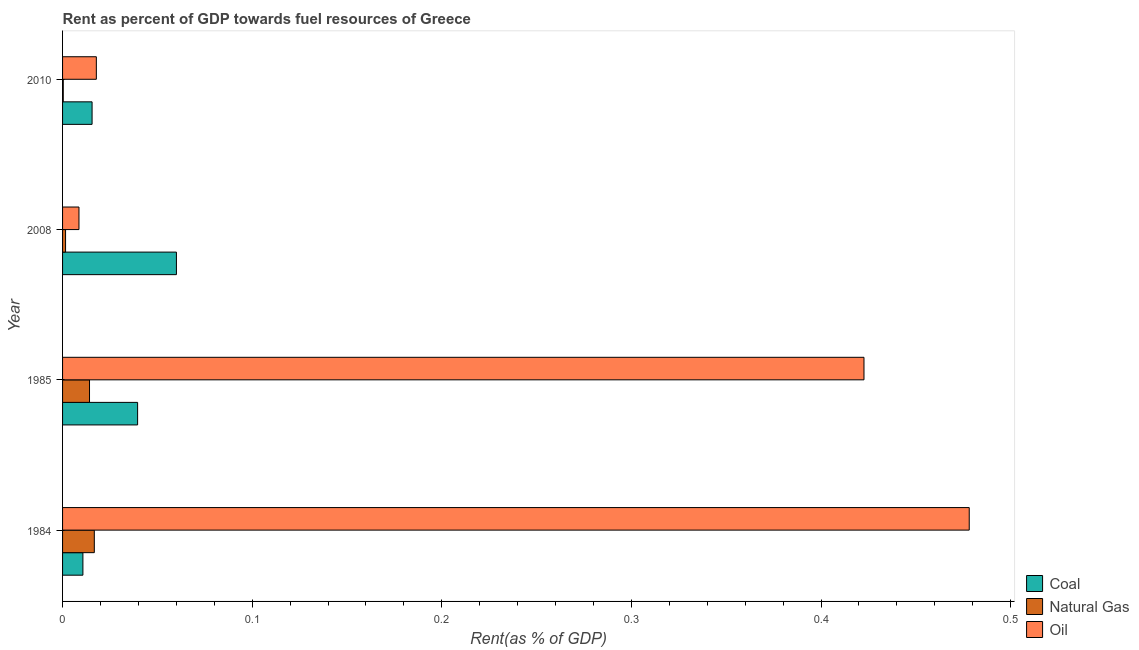What is the label of the 4th group of bars from the top?
Keep it short and to the point. 1984. What is the rent towards natural gas in 2010?
Your answer should be very brief. 0. Across all years, what is the maximum rent towards coal?
Keep it short and to the point. 0.06. Across all years, what is the minimum rent towards natural gas?
Your response must be concise. 0. In which year was the rent towards oil minimum?
Provide a succinct answer. 2008. What is the total rent towards coal in the graph?
Offer a terse response. 0.13. What is the difference between the rent towards coal in 2008 and that in 2010?
Offer a very short reply. 0.04. What is the difference between the rent towards coal in 1985 and the rent towards oil in 2010?
Offer a terse response. 0.02. What is the average rent towards natural gas per year?
Your answer should be very brief. 0.01. In the year 2010, what is the difference between the rent towards coal and rent towards oil?
Provide a succinct answer. -0. What is the ratio of the rent towards natural gas in 2008 to that in 2010?
Give a very brief answer. 4.28. Is the difference between the rent towards oil in 1984 and 2010 greater than the difference between the rent towards coal in 1984 and 2010?
Give a very brief answer. Yes. What is the difference between the highest and the lowest rent towards coal?
Provide a short and direct response. 0.05. In how many years, is the rent towards oil greater than the average rent towards oil taken over all years?
Provide a succinct answer. 2. What does the 3rd bar from the top in 2010 represents?
Provide a short and direct response. Coal. What does the 1st bar from the bottom in 2010 represents?
Your response must be concise. Coal. How many bars are there?
Keep it short and to the point. 12. How many years are there in the graph?
Your answer should be very brief. 4. Where does the legend appear in the graph?
Give a very brief answer. Bottom right. What is the title of the graph?
Ensure brevity in your answer.  Rent as percent of GDP towards fuel resources of Greece. What is the label or title of the X-axis?
Your response must be concise. Rent(as % of GDP). What is the Rent(as % of GDP) in Coal in 1984?
Offer a very short reply. 0.01. What is the Rent(as % of GDP) in Natural Gas in 1984?
Offer a terse response. 0.02. What is the Rent(as % of GDP) in Oil in 1984?
Offer a very short reply. 0.48. What is the Rent(as % of GDP) in Coal in 1985?
Offer a very short reply. 0.04. What is the Rent(as % of GDP) in Natural Gas in 1985?
Your answer should be compact. 0.01. What is the Rent(as % of GDP) in Oil in 1985?
Your answer should be compact. 0.42. What is the Rent(as % of GDP) of Coal in 2008?
Keep it short and to the point. 0.06. What is the Rent(as % of GDP) of Natural Gas in 2008?
Offer a very short reply. 0. What is the Rent(as % of GDP) in Oil in 2008?
Your answer should be very brief. 0.01. What is the Rent(as % of GDP) of Coal in 2010?
Your answer should be compact. 0.02. What is the Rent(as % of GDP) in Natural Gas in 2010?
Make the answer very short. 0. What is the Rent(as % of GDP) of Oil in 2010?
Your answer should be very brief. 0.02. Across all years, what is the maximum Rent(as % of GDP) of Coal?
Your answer should be very brief. 0.06. Across all years, what is the maximum Rent(as % of GDP) of Natural Gas?
Your answer should be compact. 0.02. Across all years, what is the maximum Rent(as % of GDP) in Oil?
Your answer should be very brief. 0.48. Across all years, what is the minimum Rent(as % of GDP) in Coal?
Make the answer very short. 0.01. Across all years, what is the minimum Rent(as % of GDP) in Natural Gas?
Your response must be concise. 0. Across all years, what is the minimum Rent(as % of GDP) of Oil?
Provide a short and direct response. 0.01. What is the total Rent(as % of GDP) of Coal in the graph?
Your answer should be compact. 0.13. What is the total Rent(as % of GDP) in Natural Gas in the graph?
Your response must be concise. 0.03. What is the total Rent(as % of GDP) of Oil in the graph?
Your answer should be very brief. 0.93. What is the difference between the Rent(as % of GDP) of Coal in 1984 and that in 1985?
Make the answer very short. -0.03. What is the difference between the Rent(as % of GDP) in Natural Gas in 1984 and that in 1985?
Offer a terse response. 0. What is the difference between the Rent(as % of GDP) of Oil in 1984 and that in 1985?
Give a very brief answer. 0.06. What is the difference between the Rent(as % of GDP) in Coal in 1984 and that in 2008?
Provide a succinct answer. -0.05. What is the difference between the Rent(as % of GDP) of Natural Gas in 1984 and that in 2008?
Make the answer very short. 0.02. What is the difference between the Rent(as % of GDP) in Oil in 1984 and that in 2008?
Your response must be concise. 0.47. What is the difference between the Rent(as % of GDP) of Coal in 1984 and that in 2010?
Your response must be concise. -0. What is the difference between the Rent(as % of GDP) of Natural Gas in 1984 and that in 2010?
Provide a short and direct response. 0.02. What is the difference between the Rent(as % of GDP) of Oil in 1984 and that in 2010?
Keep it short and to the point. 0.46. What is the difference between the Rent(as % of GDP) in Coal in 1985 and that in 2008?
Make the answer very short. -0.02. What is the difference between the Rent(as % of GDP) of Natural Gas in 1985 and that in 2008?
Provide a short and direct response. 0.01. What is the difference between the Rent(as % of GDP) in Oil in 1985 and that in 2008?
Make the answer very short. 0.41. What is the difference between the Rent(as % of GDP) in Coal in 1985 and that in 2010?
Make the answer very short. 0.02. What is the difference between the Rent(as % of GDP) in Natural Gas in 1985 and that in 2010?
Offer a terse response. 0.01. What is the difference between the Rent(as % of GDP) in Oil in 1985 and that in 2010?
Your answer should be very brief. 0.4. What is the difference between the Rent(as % of GDP) of Coal in 2008 and that in 2010?
Offer a very short reply. 0.04. What is the difference between the Rent(as % of GDP) in Natural Gas in 2008 and that in 2010?
Provide a short and direct response. 0. What is the difference between the Rent(as % of GDP) in Oil in 2008 and that in 2010?
Provide a succinct answer. -0.01. What is the difference between the Rent(as % of GDP) of Coal in 1984 and the Rent(as % of GDP) of Natural Gas in 1985?
Offer a terse response. -0. What is the difference between the Rent(as % of GDP) in Coal in 1984 and the Rent(as % of GDP) in Oil in 1985?
Offer a terse response. -0.41. What is the difference between the Rent(as % of GDP) of Natural Gas in 1984 and the Rent(as % of GDP) of Oil in 1985?
Offer a terse response. -0.41. What is the difference between the Rent(as % of GDP) of Coal in 1984 and the Rent(as % of GDP) of Natural Gas in 2008?
Keep it short and to the point. 0.01. What is the difference between the Rent(as % of GDP) in Coal in 1984 and the Rent(as % of GDP) in Oil in 2008?
Offer a terse response. 0. What is the difference between the Rent(as % of GDP) of Natural Gas in 1984 and the Rent(as % of GDP) of Oil in 2008?
Your answer should be compact. 0.01. What is the difference between the Rent(as % of GDP) of Coal in 1984 and the Rent(as % of GDP) of Natural Gas in 2010?
Offer a very short reply. 0.01. What is the difference between the Rent(as % of GDP) of Coal in 1984 and the Rent(as % of GDP) of Oil in 2010?
Your answer should be very brief. -0.01. What is the difference between the Rent(as % of GDP) in Natural Gas in 1984 and the Rent(as % of GDP) in Oil in 2010?
Offer a terse response. -0. What is the difference between the Rent(as % of GDP) in Coal in 1985 and the Rent(as % of GDP) in Natural Gas in 2008?
Your answer should be compact. 0.04. What is the difference between the Rent(as % of GDP) in Coal in 1985 and the Rent(as % of GDP) in Oil in 2008?
Keep it short and to the point. 0.03. What is the difference between the Rent(as % of GDP) in Natural Gas in 1985 and the Rent(as % of GDP) in Oil in 2008?
Your answer should be very brief. 0.01. What is the difference between the Rent(as % of GDP) in Coal in 1985 and the Rent(as % of GDP) in Natural Gas in 2010?
Keep it short and to the point. 0.04. What is the difference between the Rent(as % of GDP) of Coal in 1985 and the Rent(as % of GDP) of Oil in 2010?
Keep it short and to the point. 0.02. What is the difference between the Rent(as % of GDP) in Natural Gas in 1985 and the Rent(as % of GDP) in Oil in 2010?
Your answer should be compact. -0. What is the difference between the Rent(as % of GDP) of Coal in 2008 and the Rent(as % of GDP) of Natural Gas in 2010?
Offer a very short reply. 0.06. What is the difference between the Rent(as % of GDP) in Coal in 2008 and the Rent(as % of GDP) in Oil in 2010?
Make the answer very short. 0.04. What is the difference between the Rent(as % of GDP) of Natural Gas in 2008 and the Rent(as % of GDP) of Oil in 2010?
Offer a terse response. -0.02. What is the average Rent(as % of GDP) of Coal per year?
Your answer should be compact. 0.03. What is the average Rent(as % of GDP) in Natural Gas per year?
Ensure brevity in your answer.  0.01. What is the average Rent(as % of GDP) in Oil per year?
Keep it short and to the point. 0.23. In the year 1984, what is the difference between the Rent(as % of GDP) in Coal and Rent(as % of GDP) in Natural Gas?
Your answer should be compact. -0.01. In the year 1984, what is the difference between the Rent(as % of GDP) of Coal and Rent(as % of GDP) of Oil?
Make the answer very short. -0.47. In the year 1984, what is the difference between the Rent(as % of GDP) of Natural Gas and Rent(as % of GDP) of Oil?
Your answer should be compact. -0.46. In the year 1985, what is the difference between the Rent(as % of GDP) in Coal and Rent(as % of GDP) in Natural Gas?
Offer a terse response. 0.03. In the year 1985, what is the difference between the Rent(as % of GDP) in Coal and Rent(as % of GDP) in Oil?
Your answer should be very brief. -0.38. In the year 1985, what is the difference between the Rent(as % of GDP) of Natural Gas and Rent(as % of GDP) of Oil?
Your answer should be compact. -0.41. In the year 2008, what is the difference between the Rent(as % of GDP) of Coal and Rent(as % of GDP) of Natural Gas?
Make the answer very short. 0.06. In the year 2008, what is the difference between the Rent(as % of GDP) of Coal and Rent(as % of GDP) of Oil?
Your answer should be compact. 0.05. In the year 2008, what is the difference between the Rent(as % of GDP) of Natural Gas and Rent(as % of GDP) of Oil?
Ensure brevity in your answer.  -0.01. In the year 2010, what is the difference between the Rent(as % of GDP) in Coal and Rent(as % of GDP) in Natural Gas?
Ensure brevity in your answer.  0.02. In the year 2010, what is the difference between the Rent(as % of GDP) of Coal and Rent(as % of GDP) of Oil?
Keep it short and to the point. -0. In the year 2010, what is the difference between the Rent(as % of GDP) of Natural Gas and Rent(as % of GDP) of Oil?
Provide a succinct answer. -0.02. What is the ratio of the Rent(as % of GDP) in Coal in 1984 to that in 1985?
Make the answer very short. 0.27. What is the ratio of the Rent(as % of GDP) in Natural Gas in 1984 to that in 1985?
Provide a short and direct response. 1.18. What is the ratio of the Rent(as % of GDP) of Oil in 1984 to that in 1985?
Keep it short and to the point. 1.13. What is the ratio of the Rent(as % of GDP) in Coal in 1984 to that in 2008?
Ensure brevity in your answer.  0.18. What is the ratio of the Rent(as % of GDP) in Natural Gas in 1984 to that in 2008?
Offer a very short reply. 10.57. What is the ratio of the Rent(as % of GDP) in Oil in 1984 to that in 2008?
Ensure brevity in your answer.  55.26. What is the ratio of the Rent(as % of GDP) in Coal in 1984 to that in 2010?
Give a very brief answer. 0.69. What is the ratio of the Rent(as % of GDP) in Natural Gas in 1984 to that in 2010?
Offer a terse response. 45.2. What is the ratio of the Rent(as % of GDP) of Oil in 1984 to that in 2010?
Provide a short and direct response. 26.84. What is the ratio of the Rent(as % of GDP) of Coal in 1985 to that in 2008?
Your answer should be very brief. 0.66. What is the ratio of the Rent(as % of GDP) of Natural Gas in 1985 to that in 2008?
Your answer should be very brief. 8.97. What is the ratio of the Rent(as % of GDP) of Oil in 1985 to that in 2008?
Your response must be concise. 48.84. What is the ratio of the Rent(as % of GDP) of Coal in 1985 to that in 2010?
Provide a short and direct response. 2.54. What is the ratio of the Rent(as % of GDP) of Natural Gas in 1985 to that in 2010?
Give a very brief answer. 38.38. What is the ratio of the Rent(as % of GDP) in Oil in 1985 to that in 2010?
Offer a very short reply. 23.73. What is the ratio of the Rent(as % of GDP) in Coal in 2008 to that in 2010?
Make the answer very short. 3.86. What is the ratio of the Rent(as % of GDP) in Natural Gas in 2008 to that in 2010?
Provide a short and direct response. 4.28. What is the ratio of the Rent(as % of GDP) in Oil in 2008 to that in 2010?
Ensure brevity in your answer.  0.49. What is the difference between the highest and the second highest Rent(as % of GDP) in Coal?
Your response must be concise. 0.02. What is the difference between the highest and the second highest Rent(as % of GDP) in Natural Gas?
Your answer should be compact. 0. What is the difference between the highest and the second highest Rent(as % of GDP) in Oil?
Keep it short and to the point. 0.06. What is the difference between the highest and the lowest Rent(as % of GDP) in Coal?
Keep it short and to the point. 0.05. What is the difference between the highest and the lowest Rent(as % of GDP) in Natural Gas?
Make the answer very short. 0.02. What is the difference between the highest and the lowest Rent(as % of GDP) of Oil?
Your response must be concise. 0.47. 